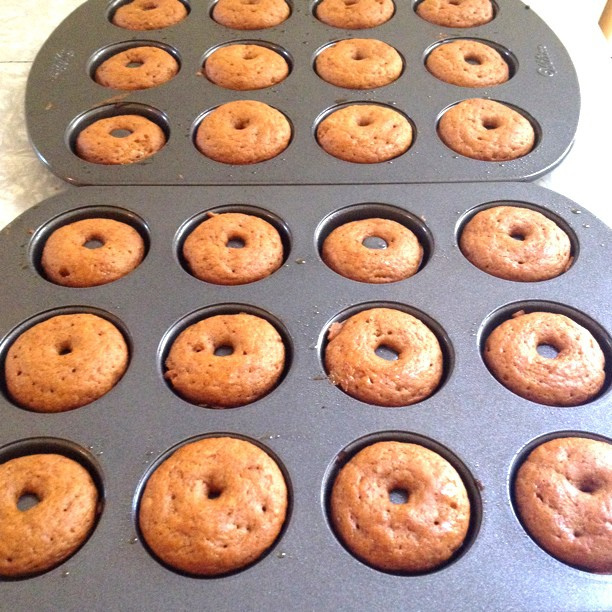What might be an occasion for making so many donuts at once? Baking a large batch of donuts could be for an event such as a party, a bake sale, a meeting, or simply to have treats prepared for the week ahead. Could you suggest an icing or topping that would go well with these donuts? A classic sugar glaze or chocolate icing would complement these donuts well. Other options could include sprinkles, crushed nuts, or a dusting of powdered sugar. 